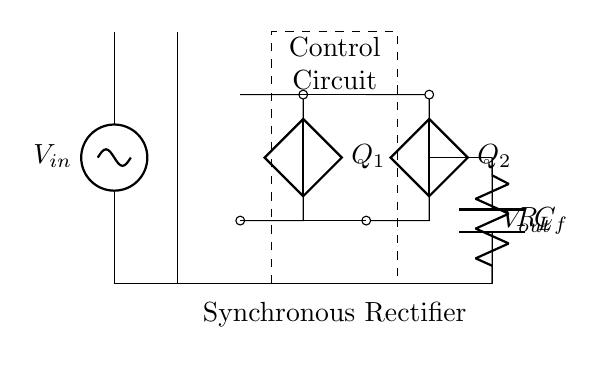What is the type of rectifier shown in the diagram? The diagram depicts a synchronous rectifier, indicated by the presence of control circuits and switches labeled Q1 and Q2 that actively manage the rectification process.
Answer: synchronous rectifier What are the components used for rectification in this circuit? The components used for rectification are labeled Q1 and Q2, which are the switches in the synchronous rectifier that control the conversion of AC to DC.
Answer: Q1, Q2 What does the label C_f represent in the circuit? The label C_f represents the filter capacitor, which smooths the output voltage by reducing ripple after the rectification process.
Answer: filter capacitor How many phases does the input AC source provide? The input AC source is typically single-phase in most studio amplifier designs; however, based on the circuit's complexity, one could verify the phase by checking if more components are present.
Answer: single-phase What is the purpose of the control circuit in this rectifier? The control circuit actively manages the operation of the switches Q1 and Q2 to improve efficiency during the rectification process by minimizing the conduction losses typically found in diode-based rectifiers.
Answer: improve efficiency How does the output voltage, V_out, relate to the input voltage, V_in? The output voltage, V_out, will be less than the input voltage, V_in, primarily due to voltage drops across the switches Q1 and Q2 in the synchronous rectifier. The filter capacitor C_f further smooths this output.
Answer: less than V_in 